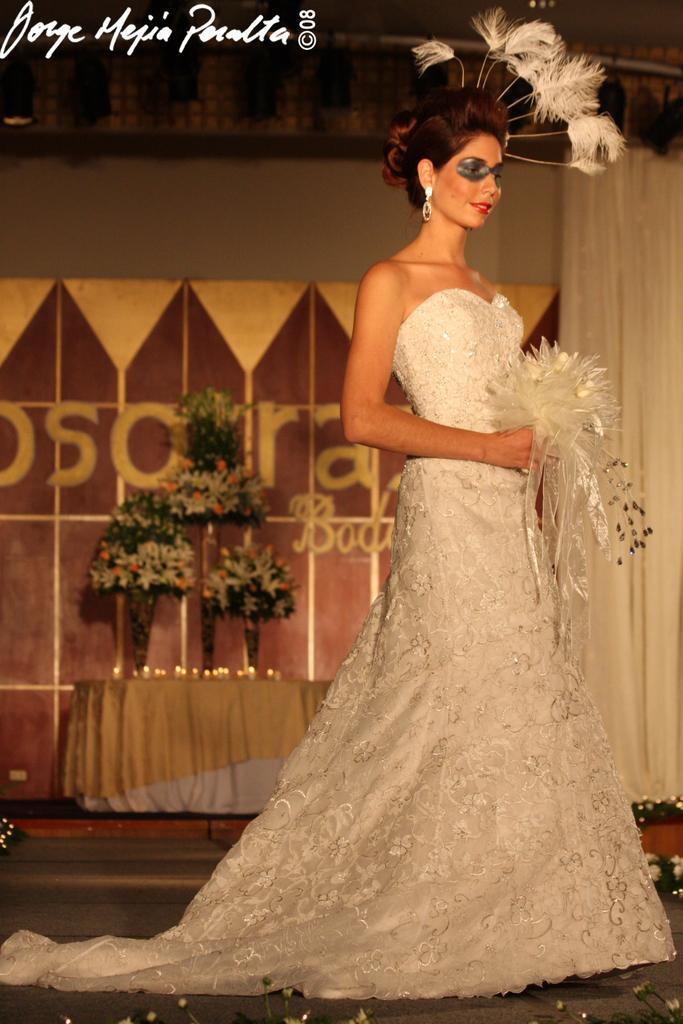Please provide a concise description of this image. In this image we can see a woman standing on the floor and holding an artificial bouquet in the hands. In the background there are curtain, flower vases and candles placed on the table. 